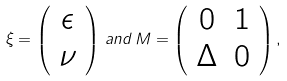Convert formula to latex. <formula><loc_0><loc_0><loc_500><loc_500>\xi = \left ( \begin{array} { c } \epsilon \\ \nu \end{array} \right ) \, a n d \, M = \left ( \begin{array} { c c } 0 & 1 \\ \Delta & 0 \end{array} \right ) ,</formula> 